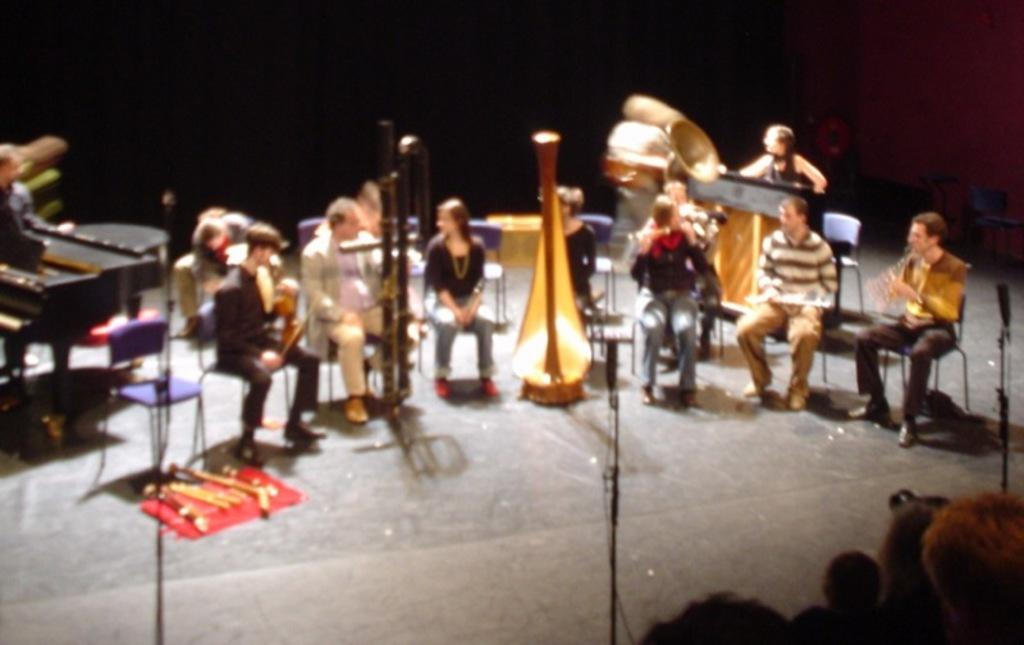What are the people in the image doing? The people in the image are sitting on chairs. What else can be seen in the image besides the people sitting on chairs? There are musical instruments in the image. What type of disease is being treated by the people in the image? There is no indication of any disease or medical treatment in the image; the people are simply sitting on chairs. 